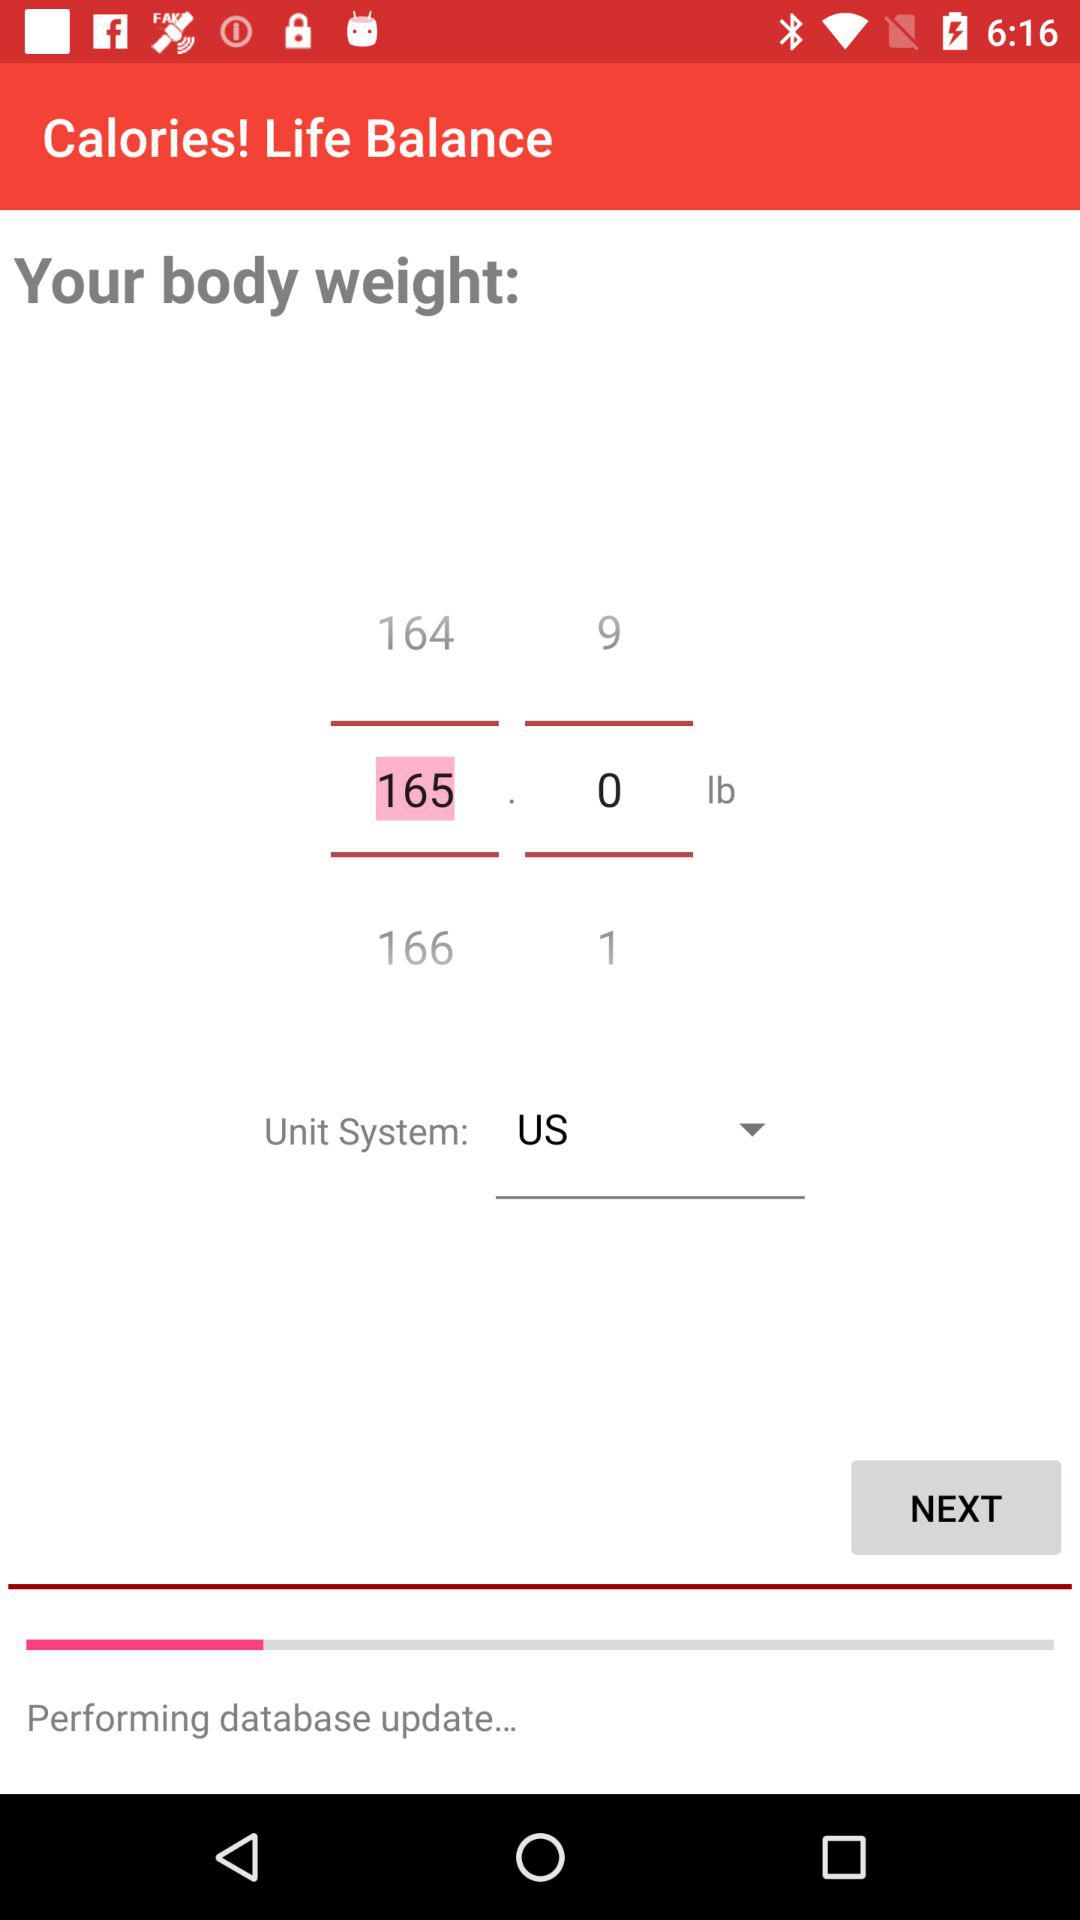What is the unit of weight? The unit of weight is pounds. 